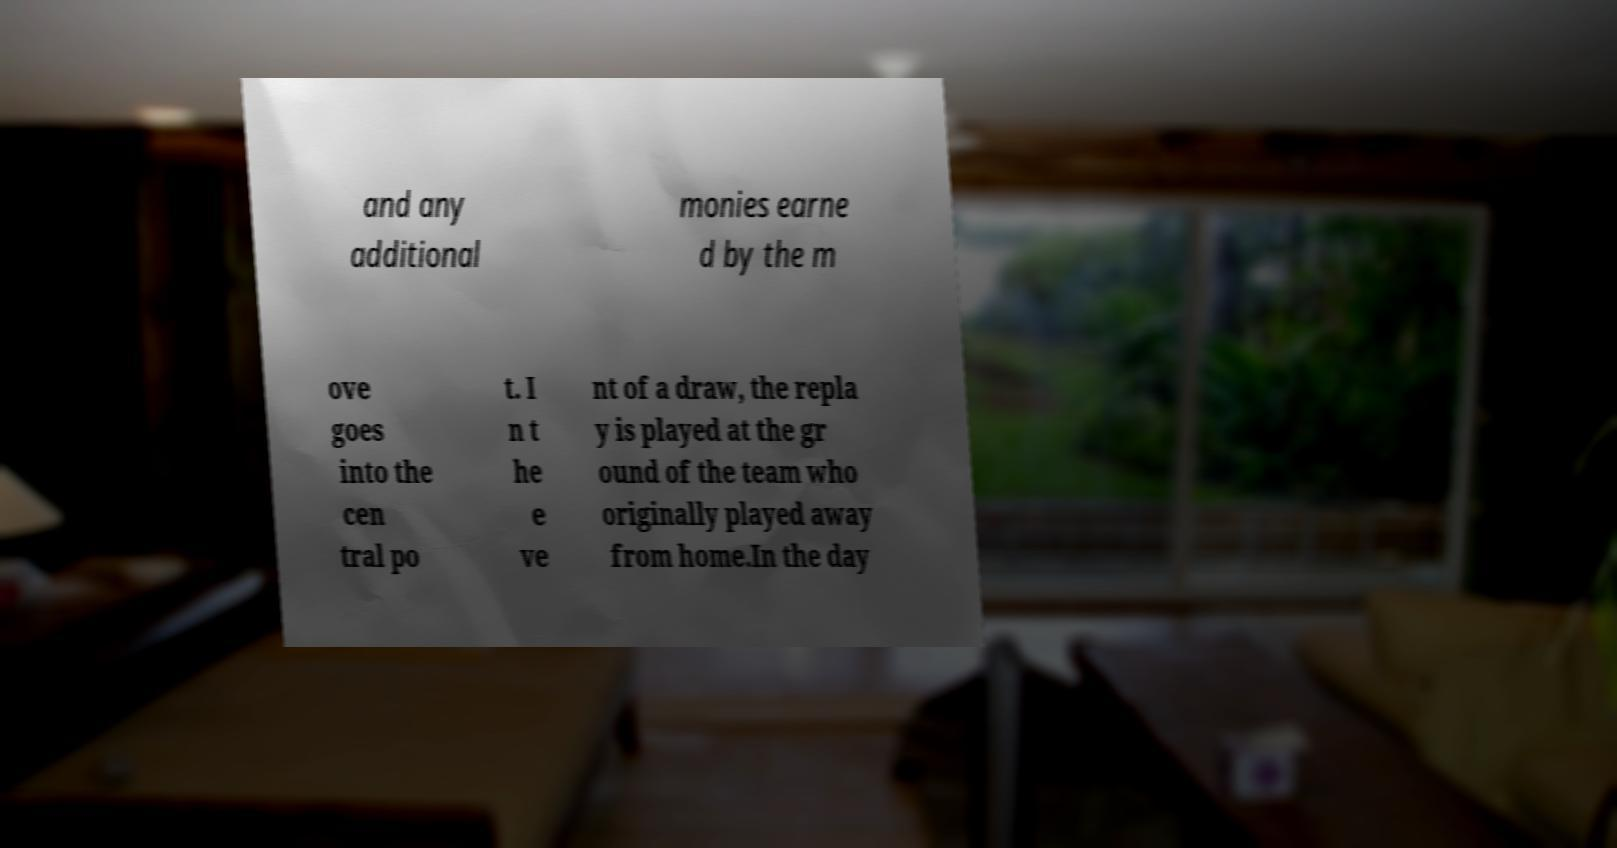Could you extract and type out the text from this image? and any additional monies earne d by the m ove goes into the cen tral po t. I n t he e ve nt of a draw, the repla y is played at the gr ound of the team who originally played away from home.In the day 